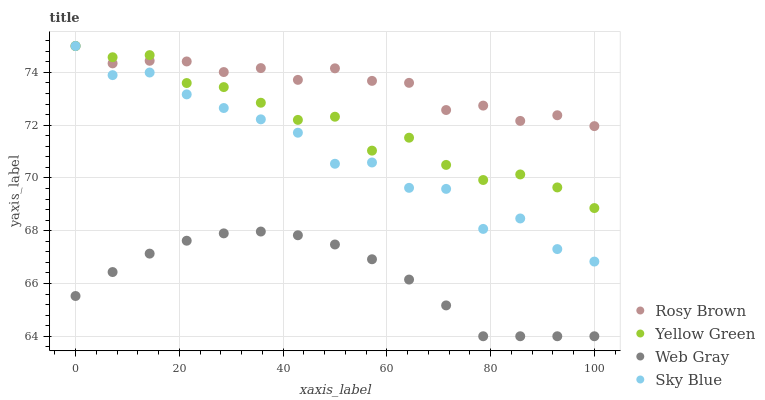Does Web Gray have the minimum area under the curve?
Answer yes or no. Yes. Does Rosy Brown have the maximum area under the curve?
Answer yes or no. Yes. Does Rosy Brown have the minimum area under the curve?
Answer yes or no. No. Does Web Gray have the maximum area under the curve?
Answer yes or no. No. Is Web Gray the smoothest?
Answer yes or no. Yes. Is Sky Blue the roughest?
Answer yes or no. Yes. Is Rosy Brown the smoothest?
Answer yes or no. No. Is Rosy Brown the roughest?
Answer yes or no. No. Does Web Gray have the lowest value?
Answer yes or no. Yes. Does Rosy Brown have the lowest value?
Answer yes or no. No. Does Yellow Green have the highest value?
Answer yes or no. Yes. Does Web Gray have the highest value?
Answer yes or no. No. Is Web Gray less than Yellow Green?
Answer yes or no. Yes. Is Sky Blue greater than Web Gray?
Answer yes or no. Yes. Does Sky Blue intersect Rosy Brown?
Answer yes or no. Yes. Is Sky Blue less than Rosy Brown?
Answer yes or no. No. Is Sky Blue greater than Rosy Brown?
Answer yes or no. No. Does Web Gray intersect Yellow Green?
Answer yes or no. No. 